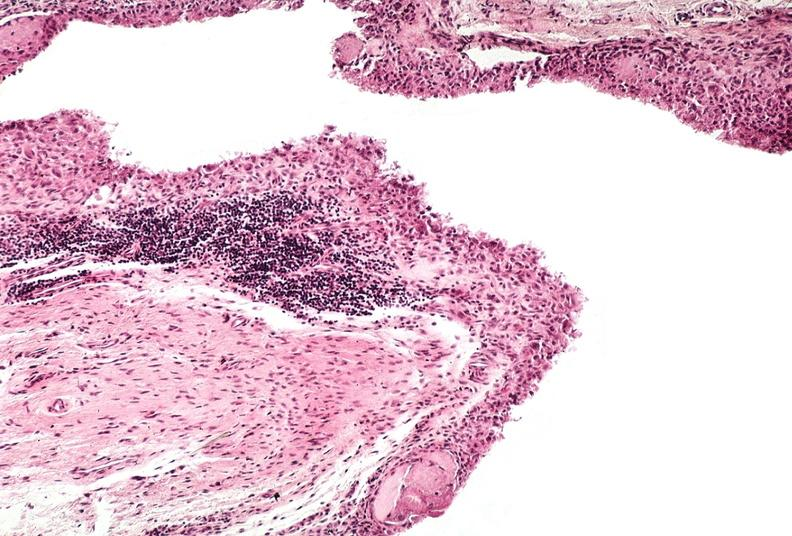does this image show synovial proliferation, villous, rheumatoid arthritis?
Answer the question using a single word or phrase. Yes 